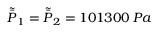Convert formula to latex. <formula><loc_0><loc_0><loc_500><loc_500>\tilde { \bar { P } } _ { 1 } = \tilde { \bar { P } } _ { 2 } = 1 0 1 3 0 0 \, P a</formula> 